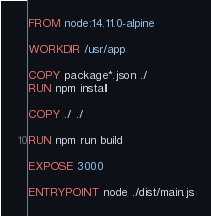<code> <loc_0><loc_0><loc_500><loc_500><_Dockerfile_>FROM node:14.11.0-alpine

WORKDIR /usr/app

COPY package*.json ./
RUN npm install

COPY ./ ./

RUN npm run build

EXPOSE 3000

ENTRYPOINT node ./dist/main.js
</code> 